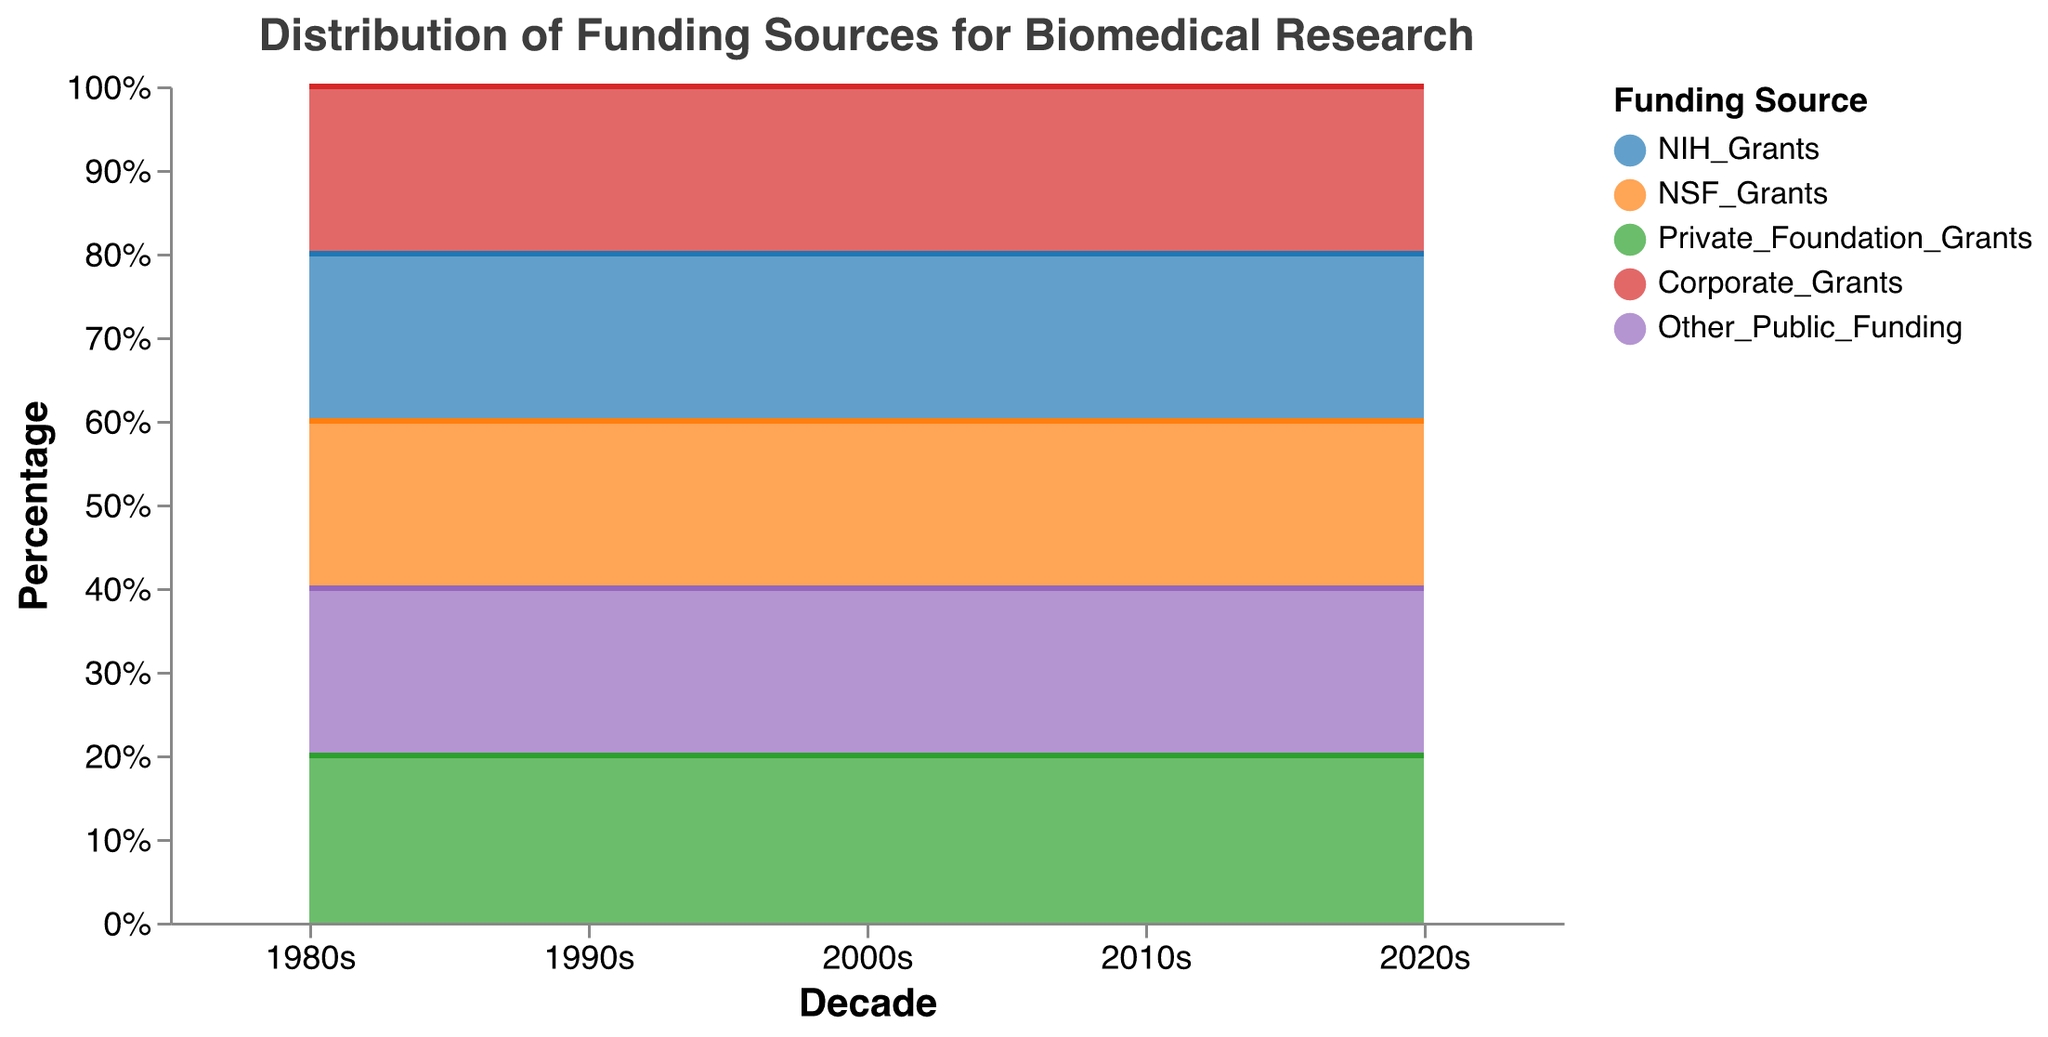What is the title of the figure? The title of the figure is located at the top and provides an overview of what the chart represents.
Answer: Distribution of Funding Sources for Biomedical Research Which decade shows the highest percentage of NIH Grants? By examining the area representing NIH Grants (the color defined for NIH Grants in the legend) across all decades, we identify the decade with the largest area for NIH Grants.
Answer: 1980s What is the trend for Corporate Grants from the 1980s to the 2020s? By observing the area allocated to Corporate Grants across the decades, it is evident how the percentage changes over time. The trend involves increasing or decreasing the area over the period.
Answer: Increasing Which funding source has seen a steady increase in percentage from the 1980s to the 2020s? By comparing the areas of different funding sources over the decades and identifying which source shows a consistent increment, we determine which funding source has increased steadily.
Answer: Private Foundation Grants How does the percentage of NSF Grants in the 2000s compare to the 2020s? By comparing the area representing NSF Grants in the 2000s to that of the 2020s, we can see if it has increased, decreased, or remained the same.
Answer: Decreased Between NIH Grants and NSF Grants, which one has a larger percentage in the 2010s? By comparing the areas allocated to NIH Grants and NSF Grants in the 2010s, we determine which one occupies a larger area.
Answer: NSF Grants What is the total percentage of Private Foundation Grants and Corporate Grants in the 2020s? By summing the percentage areas of Private Foundation Grants and Corporate Grants in the 2020s, we get the total percentage.
Answer: 45% Has the share of NIH Grants increased or decreased from the 1980s to the 2010s? By comparing the NIH Grants percentage area in the 1980s to that in the 2010s, we can ascertain if the share has increased or decreased.
Answer: Decreased Which funding source had the smallest percentage in the 1990s and what was its percentage? Looking at the different funding sources in the 1990s, identify which has the smallest area and note the percentage.
Answer: Other Public Funding, 5% 